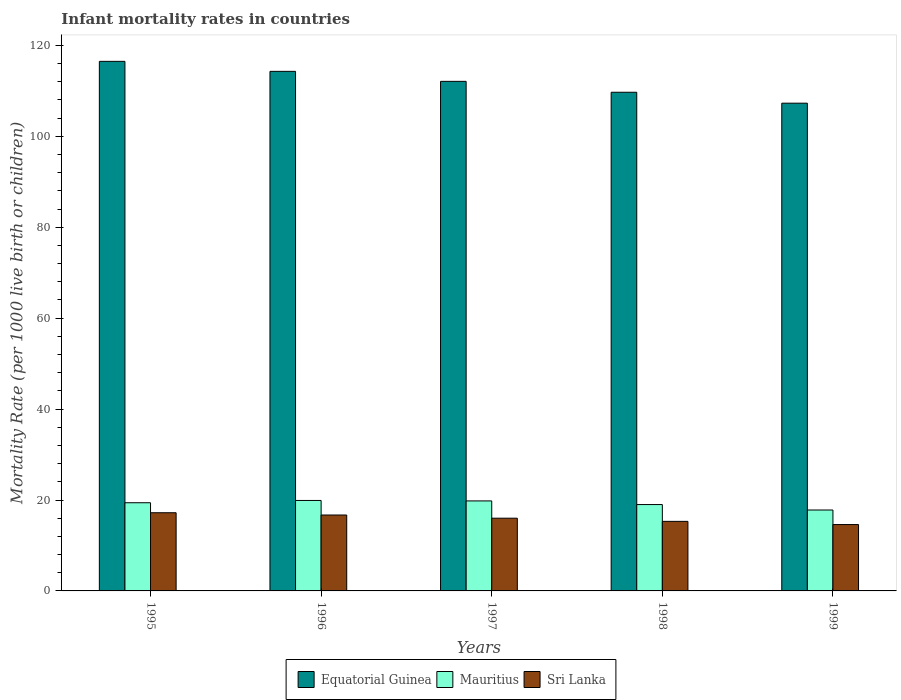How many different coloured bars are there?
Make the answer very short. 3. How many groups of bars are there?
Make the answer very short. 5. Are the number of bars on each tick of the X-axis equal?
Your answer should be compact. Yes. How many bars are there on the 2nd tick from the right?
Keep it short and to the point. 3. What is the label of the 4th group of bars from the left?
Provide a succinct answer. 1998. What is the infant mortality rate in Mauritius in 1995?
Your answer should be compact. 19.4. Across all years, what is the maximum infant mortality rate in Equatorial Guinea?
Offer a very short reply. 116.5. Across all years, what is the minimum infant mortality rate in Equatorial Guinea?
Give a very brief answer. 107.3. In which year was the infant mortality rate in Mauritius minimum?
Keep it short and to the point. 1999. What is the total infant mortality rate in Mauritius in the graph?
Your response must be concise. 95.9. What is the difference between the infant mortality rate in Mauritius in 1995 and that in 1999?
Provide a short and direct response. 1.6. What is the difference between the infant mortality rate in Sri Lanka in 1998 and the infant mortality rate in Equatorial Guinea in 1997?
Provide a succinct answer. -96.8. What is the average infant mortality rate in Sri Lanka per year?
Your answer should be very brief. 15.96. In the year 1997, what is the difference between the infant mortality rate in Mauritius and infant mortality rate in Sri Lanka?
Ensure brevity in your answer.  3.8. In how many years, is the infant mortality rate in Equatorial Guinea greater than 60?
Make the answer very short. 5. What is the ratio of the infant mortality rate in Mauritius in 1995 to that in 1998?
Offer a terse response. 1.02. Is the infant mortality rate in Mauritius in 1995 less than that in 1998?
Your answer should be very brief. No. What is the difference between the highest and the second highest infant mortality rate in Sri Lanka?
Offer a very short reply. 0.5. What is the difference between the highest and the lowest infant mortality rate in Mauritius?
Your answer should be very brief. 2.1. In how many years, is the infant mortality rate in Sri Lanka greater than the average infant mortality rate in Sri Lanka taken over all years?
Offer a very short reply. 3. Is the sum of the infant mortality rate in Mauritius in 1995 and 1999 greater than the maximum infant mortality rate in Equatorial Guinea across all years?
Ensure brevity in your answer.  No. What does the 1st bar from the left in 1996 represents?
Your response must be concise. Equatorial Guinea. What does the 2nd bar from the right in 1999 represents?
Offer a terse response. Mauritius. How many bars are there?
Make the answer very short. 15. Are all the bars in the graph horizontal?
Keep it short and to the point. No. How many years are there in the graph?
Give a very brief answer. 5. What is the difference between two consecutive major ticks on the Y-axis?
Your answer should be compact. 20. Does the graph contain any zero values?
Give a very brief answer. No. How many legend labels are there?
Offer a very short reply. 3. What is the title of the graph?
Provide a succinct answer. Infant mortality rates in countries. What is the label or title of the X-axis?
Your answer should be compact. Years. What is the label or title of the Y-axis?
Your answer should be compact. Mortality Rate (per 1000 live birth or children). What is the Mortality Rate (per 1000 live birth or children) in Equatorial Guinea in 1995?
Ensure brevity in your answer.  116.5. What is the Mortality Rate (per 1000 live birth or children) in Equatorial Guinea in 1996?
Keep it short and to the point. 114.3. What is the Mortality Rate (per 1000 live birth or children) in Mauritius in 1996?
Give a very brief answer. 19.9. What is the Mortality Rate (per 1000 live birth or children) in Sri Lanka in 1996?
Give a very brief answer. 16.7. What is the Mortality Rate (per 1000 live birth or children) of Equatorial Guinea in 1997?
Offer a terse response. 112.1. What is the Mortality Rate (per 1000 live birth or children) in Mauritius in 1997?
Your answer should be compact. 19.8. What is the Mortality Rate (per 1000 live birth or children) of Equatorial Guinea in 1998?
Keep it short and to the point. 109.7. What is the Mortality Rate (per 1000 live birth or children) in Mauritius in 1998?
Your answer should be compact. 19. What is the Mortality Rate (per 1000 live birth or children) of Equatorial Guinea in 1999?
Your answer should be compact. 107.3. What is the Mortality Rate (per 1000 live birth or children) of Sri Lanka in 1999?
Offer a terse response. 14.6. Across all years, what is the maximum Mortality Rate (per 1000 live birth or children) of Equatorial Guinea?
Your response must be concise. 116.5. Across all years, what is the minimum Mortality Rate (per 1000 live birth or children) in Equatorial Guinea?
Give a very brief answer. 107.3. Across all years, what is the minimum Mortality Rate (per 1000 live birth or children) in Mauritius?
Offer a very short reply. 17.8. Across all years, what is the minimum Mortality Rate (per 1000 live birth or children) of Sri Lanka?
Your answer should be very brief. 14.6. What is the total Mortality Rate (per 1000 live birth or children) of Equatorial Guinea in the graph?
Provide a short and direct response. 559.9. What is the total Mortality Rate (per 1000 live birth or children) in Mauritius in the graph?
Offer a terse response. 95.9. What is the total Mortality Rate (per 1000 live birth or children) in Sri Lanka in the graph?
Offer a terse response. 79.8. What is the difference between the Mortality Rate (per 1000 live birth or children) of Mauritius in 1995 and that in 1996?
Make the answer very short. -0.5. What is the difference between the Mortality Rate (per 1000 live birth or children) in Equatorial Guinea in 1995 and that in 1998?
Give a very brief answer. 6.8. What is the difference between the Mortality Rate (per 1000 live birth or children) in Equatorial Guinea in 1995 and that in 1999?
Your response must be concise. 9.2. What is the difference between the Mortality Rate (per 1000 live birth or children) of Mauritius in 1995 and that in 1999?
Make the answer very short. 1.6. What is the difference between the Mortality Rate (per 1000 live birth or children) of Sri Lanka in 1995 and that in 1999?
Your response must be concise. 2.6. What is the difference between the Mortality Rate (per 1000 live birth or children) in Equatorial Guinea in 1996 and that in 1997?
Make the answer very short. 2.2. What is the difference between the Mortality Rate (per 1000 live birth or children) in Equatorial Guinea in 1996 and that in 1998?
Your answer should be compact. 4.6. What is the difference between the Mortality Rate (per 1000 live birth or children) in Sri Lanka in 1996 and that in 1998?
Offer a terse response. 1.4. What is the difference between the Mortality Rate (per 1000 live birth or children) in Mauritius in 1997 and that in 1998?
Provide a succinct answer. 0.8. What is the difference between the Mortality Rate (per 1000 live birth or children) in Sri Lanka in 1997 and that in 1998?
Ensure brevity in your answer.  0.7. What is the difference between the Mortality Rate (per 1000 live birth or children) of Equatorial Guinea in 1997 and that in 1999?
Your response must be concise. 4.8. What is the difference between the Mortality Rate (per 1000 live birth or children) in Mauritius in 1997 and that in 1999?
Provide a succinct answer. 2. What is the difference between the Mortality Rate (per 1000 live birth or children) of Equatorial Guinea in 1998 and that in 1999?
Give a very brief answer. 2.4. What is the difference between the Mortality Rate (per 1000 live birth or children) in Mauritius in 1998 and that in 1999?
Make the answer very short. 1.2. What is the difference between the Mortality Rate (per 1000 live birth or children) in Equatorial Guinea in 1995 and the Mortality Rate (per 1000 live birth or children) in Mauritius in 1996?
Offer a very short reply. 96.6. What is the difference between the Mortality Rate (per 1000 live birth or children) of Equatorial Guinea in 1995 and the Mortality Rate (per 1000 live birth or children) of Sri Lanka in 1996?
Ensure brevity in your answer.  99.8. What is the difference between the Mortality Rate (per 1000 live birth or children) in Mauritius in 1995 and the Mortality Rate (per 1000 live birth or children) in Sri Lanka in 1996?
Give a very brief answer. 2.7. What is the difference between the Mortality Rate (per 1000 live birth or children) of Equatorial Guinea in 1995 and the Mortality Rate (per 1000 live birth or children) of Mauritius in 1997?
Your answer should be very brief. 96.7. What is the difference between the Mortality Rate (per 1000 live birth or children) in Equatorial Guinea in 1995 and the Mortality Rate (per 1000 live birth or children) in Sri Lanka in 1997?
Make the answer very short. 100.5. What is the difference between the Mortality Rate (per 1000 live birth or children) in Equatorial Guinea in 1995 and the Mortality Rate (per 1000 live birth or children) in Mauritius in 1998?
Your answer should be compact. 97.5. What is the difference between the Mortality Rate (per 1000 live birth or children) in Equatorial Guinea in 1995 and the Mortality Rate (per 1000 live birth or children) in Sri Lanka in 1998?
Keep it short and to the point. 101.2. What is the difference between the Mortality Rate (per 1000 live birth or children) in Mauritius in 1995 and the Mortality Rate (per 1000 live birth or children) in Sri Lanka in 1998?
Your answer should be very brief. 4.1. What is the difference between the Mortality Rate (per 1000 live birth or children) of Equatorial Guinea in 1995 and the Mortality Rate (per 1000 live birth or children) of Mauritius in 1999?
Ensure brevity in your answer.  98.7. What is the difference between the Mortality Rate (per 1000 live birth or children) of Equatorial Guinea in 1995 and the Mortality Rate (per 1000 live birth or children) of Sri Lanka in 1999?
Provide a short and direct response. 101.9. What is the difference between the Mortality Rate (per 1000 live birth or children) in Equatorial Guinea in 1996 and the Mortality Rate (per 1000 live birth or children) in Mauritius in 1997?
Your response must be concise. 94.5. What is the difference between the Mortality Rate (per 1000 live birth or children) of Equatorial Guinea in 1996 and the Mortality Rate (per 1000 live birth or children) of Sri Lanka in 1997?
Offer a terse response. 98.3. What is the difference between the Mortality Rate (per 1000 live birth or children) in Equatorial Guinea in 1996 and the Mortality Rate (per 1000 live birth or children) in Mauritius in 1998?
Offer a very short reply. 95.3. What is the difference between the Mortality Rate (per 1000 live birth or children) of Equatorial Guinea in 1996 and the Mortality Rate (per 1000 live birth or children) of Sri Lanka in 1998?
Keep it short and to the point. 99. What is the difference between the Mortality Rate (per 1000 live birth or children) in Mauritius in 1996 and the Mortality Rate (per 1000 live birth or children) in Sri Lanka in 1998?
Keep it short and to the point. 4.6. What is the difference between the Mortality Rate (per 1000 live birth or children) of Equatorial Guinea in 1996 and the Mortality Rate (per 1000 live birth or children) of Mauritius in 1999?
Provide a succinct answer. 96.5. What is the difference between the Mortality Rate (per 1000 live birth or children) of Equatorial Guinea in 1996 and the Mortality Rate (per 1000 live birth or children) of Sri Lanka in 1999?
Keep it short and to the point. 99.7. What is the difference between the Mortality Rate (per 1000 live birth or children) in Mauritius in 1996 and the Mortality Rate (per 1000 live birth or children) in Sri Lanka in 1999?
Offer a terse response. 5.3. What is the difference between the Mortality Rate (per 1000 live birth or children) in Equatorial Guinea in 1997 and the Mortality Rate (per 1000 live birth or children) in Mauritius in 1998?
Give a very brief answer. 93.1. What is the difference between the Mortality Rate (per 1000 live birth or children) of Equatorial Guinea in 1997 and the Mortality Rate (per 1000 live birth or children) of Sri Lanka in 1998?
Ensure brevity in your answer.  96.8. What is the difference between the Mortality Rate (per 1000 live birth or children) of Equatorial Guinea in 1997 and the Mortality Rate (per 1000 live birth or children) of Mauritius in 1999?
Make the answer very short. 94.3. What is the difference between the Mortality Rate (per 1000 live birth or children) in Equatorial Guinea in 1997 and the Mortality Rate (per 1000 live birth or children) in Sri Lanka in 1999?
Your answer should be compact. 97.5. What is the difference between the Mortality Rate (per 1000 live birth or children) of Mauritius in 1997 and the Mortality Rate (per 1000 live birth or children) of Sri Lanka in 1999?
Give a very brief answer. 5.2. What is the difference between the Mortality Rate (per 1000 live birth or children) in Equatorial Guinea in 1998 and the Mortality Rate (per 1000 live birth or children) in Mauritius in 1999?
Give a very brief answer. 91.9. What is the difference between the Mortality Rate (per 1000 live birth or children) in Equatorial Guinea in 1998 and the Mortality Rate (per 1000 live birth or children) in Sri Lanka in 1999?
Keep it short and to the point. 95.1. What is the average Mortality Rate (per 1000 live birth or children) in Equatorial Guinea per year?
Your answer should be very brief. 111.98. What is the average Mortality Rate (per 1000 live birth or children) in Mauritius per year?
Provide a succinct answer. 19.18. What is the average Mortality Rate (per 1000 live birth or children) of Sri Lanka per year?
Make the answer very short. 15.96. In the year 1995, what is the difference between the Mortality Rate (per 1000 live birth or children) in Equatorial Guinea and Mortality Rate (per 1000 live birth or children) in Mauritius?
Give a very brief answer. 97.1. In the year 1995, what is the difference between the Mortality Rate (per 1000 live birth or children) of Equatorial Guinea and Mortality Rate (per 1000 live birth or children) of Sri Lanka?
Your response must be concise. 99.3. In the year 1995, what is the difference between the Mortality Rate (per 1000 live birth or children) in Mauritius and Mortality Rate (per 1000 live birth or children) in Sri Lanka?
Offer a very short reply. 2.2. In the year 1996, what is the difference between the Mortality Rate (per 1000 live birth or children) of Equatorial Guinea and Mortality Rate (per 1000 live birth or children) of Mauritius?
Your response must be concise. 94.4. In the year 1996, what is the difference between the Mortality Rate (per 1000 live birth or children) in Equatorial Guinea and Mortality Rate (per 1000 live birth or children) in Sri Lanka?
Your response must be concise. 97.6. In the year 1996, what is the difference between the Mortality Rate (per 1000 live birth or children) of Mauritius and Mortality Rate (per 1000 live birth or children) of Sri Lanka?
Offer a very short reply. 3.2. In the year 1997, what is the difference between the Mortality Rate (per 1000 live birth or children) of Equatorial Guinea and Mortality Rate (per 1000 live birth or children) of Mauritius?
Provide a succinct answer. 92.3. In the year 1997, what is the difference between the Mortality Rate (per 1000 live birth or children) of Equatorial Guinea and Mortality Rate (per 1000 live birth or children) of Sri Lanka?
Provide a succinct answer. 96.1. In the year 1997, what is the difference between the Mortality Rate (per 1000 live birth or children) in Mauritius and Mortality Rate (per 1000 live birth or children) in Sri Lanka?
Make the answer very short. 3.8. In the year 1998, what is the difference between the Mortality Rate (per 1000 live birth or children) in Equatorial Guinea and Mortality Rate (per 1000 live birth or children) in Mauritius?
Keep it short and to the point. 90.7. In the year 1998, what is the difference between the Mortality Rate (per 1000 live birth or children) of Equatorial Guinea and Mortality Rate (per 1000 live birth or children) of Sri Lanka?
Give a very brief answer. 94.4. In the year 1998, what is the difference between the Mortality Rate (per 1000 live birth or children) of Mauritius and Mortality Rate (per 1000 live birth or children) of Sri Lanka?
Your answer should be compact. 3.7. In the year 1999, what is the difference between the Mortality Rate (per 1000 live birth or children) of Equatorial Guinea and Mortality Rate (per 1000 live birth or children) of Mauritius?
Give a very brief answer. 89.5. In the year 1999, what is the difference between the Mortality Rate (per 1000 live birth or children) of Equatorial Guinea and Mortality Rate (per 1000 live birth or children) of Sri Lanka?
Make the answer very short. 92.7. What is the ratio of the Mortality Rate (per 1000 live birth or children) of Equatorial Guinea in 1995 to that in 1996?
Provide a succinct answer. 1.02. What is the ratio of the Mortality Rate (per 1000 live birth or children) in Mauritius in 1995 to that in 1996?
Provide a short and direct response. 0.97. What is the ratio of the Mortality Rate (per 1000 live birth or children) in Sri Lanka in 1995 to that in 1996?
Your response must be concise. 1.03. What is the ratio of the Mortality Rate (per 1000 live birth or children) in Equatorial Guinea in 1995 to that in 1997?
Keep it short and to the point. 1.04. What is the ratio of the Mortality Rate (per 1000 live birth or children) of Mauritius in 1995 to that in 1997?
Offer a terse response. 0.98. What is the ratio of the Mortality Rate (per 1000 live birth or children) of Sri Lanka in 1995 to that in 1997?
Your response must be concise. 1.07. What is the ratio of the Mortality Rate (per 1000 live birth or children) in Equatorial Guinea in 1995 to that in 1998?
Provide a short and direct response. 1.06. What is the ratio of the Mortality Rate (per 1000 live birth or children) of Mauritius in 1995 to that in 1998?
Provide a succinct answer. 1.02. What is the ratio of the Mortality Rate (per 1000 live birth or children) of Sri Lanka in 1995 to that in 1998?
Ensure brevity in your answer.  1.12. What is the ratio of the Mortality Rate (per 1000 live birth or children) in Equatorial Guinea in 1995 to that in 1999?
Ensure brevity in your answer.  1.09. What is the ratio of the Mortality Rate (per 1000 live birth or children) in Mauritius in 1995 to that in 1999?
Give a very brief answer. 1.09. What is the ratio of the Mortality Rate (per 1000 live birth or children) in Sri Lanka in 1995 to that in 1999?
Offer a very short reply. 1.18. What is the ratio of the Mortality Rate (per 1000 live birth or children) in Equatorial Guinea in 1996 to that in 1997?
Make the answer very short. 1.02. What is the ratio of the Mortality Rate (per 1000 live birth or children) of Sri Lanka in 1996 to that in 1997?
Provide a short and direct response. 1.04. What is the ratio of the Mortality Rate (per 1000 live birth or children) in Equatorial Guinea in 1996 to that in 1998?
Ensure brevity in your answer.  1.04. What is the ratio of the Mortality Rate (per 1000 live birth or children) in Mauritius in 1996 to that in 1998?
Make the answer very short. 1.05. What is the ratio of the Mortality Rate (per 1000 live birth or children) of Sri Lanka in 1996 to that in 1998?
Offer a very short reply. 1.09. What is the ratio of the Mortality Rate (per 1000 live birth or children) of Equatorial Guinea in 1996 to that in 1999?
Offer a terse response. 1.07. What is the ratio of the Mortality Rate (per 1000 live birth or children) of Mauritius in 1996 to that in 1999?
Ensure brevity in your answer.  1.12. What is the ratio of the Mortality Rate (per 1000 live birth or children) in Sri Lanka in 1996 to that in 1999?
Your response must be concise. 1.14. What is the ratio of the Mortality Rate (per 1000 live birth or children) of Equatorial Guinea in 1997 to that in 1998?
Ensure brevity in your answer.  1.02. What is the ratio of the Mortality Rate (per 1000 live birth or children) of Mauritius in 1997 to that in 1998?
Provide a succinct answer. 1.04. What is the ratio of the Mortality Rate (per 1000 live birth or children) in Sri Lanka in 1997 to that in 1998?
Offer a very short reply. 1.05. What is the ratio of the Mortality Rate (per 1000 live birth or children) of Equatorial Guinea in 1997 to that in 1999?
Your response must be concise. 1.04. What is the ratio of the Mortality Rate (per 1000 live birth or children) in Mauritius in 1997 to that in 1999?
Your answer should be very brief. 1.11. What is the ratio of the Mortality Rate (per 1000 live birth or children) in Sri Lanka in 1997 to that in 1999?
Offer a very short reply. 1.1. What is the ratio of the Mortality Rate (per 1000 live birth or children) of Equatorial Guinea in 1998 to that in 1999?
Your answer should be very brief. 1.02. What is the ratio of the Mortality Rate (per 1000 live birth or children) in Mauritius in 1998 to that in 1999?
Your answer should be very brief. 1.07. What is the ratio of the Mortality Rate (per 1000 live birth or children) of Sri Lanka in 1998 to that in 1999?
Ensure brevity in your answer.  1.05. What is the difference between the highest and the second highest Mortality Rate (per 1000 live birth or children) of Equatorial Guinea?
Give a very brief answer. 2.2. What is the difference between the highest and the second highest Mortality Rate (per 1000 live birth or children) of Mauritius?
Offer a very short reply. 0.1. What is the difference between the highest and the lowest Mortality Rate (per 1000 live birth or children) of Sri Lanka?
Your answer should be compact. 2.6. 